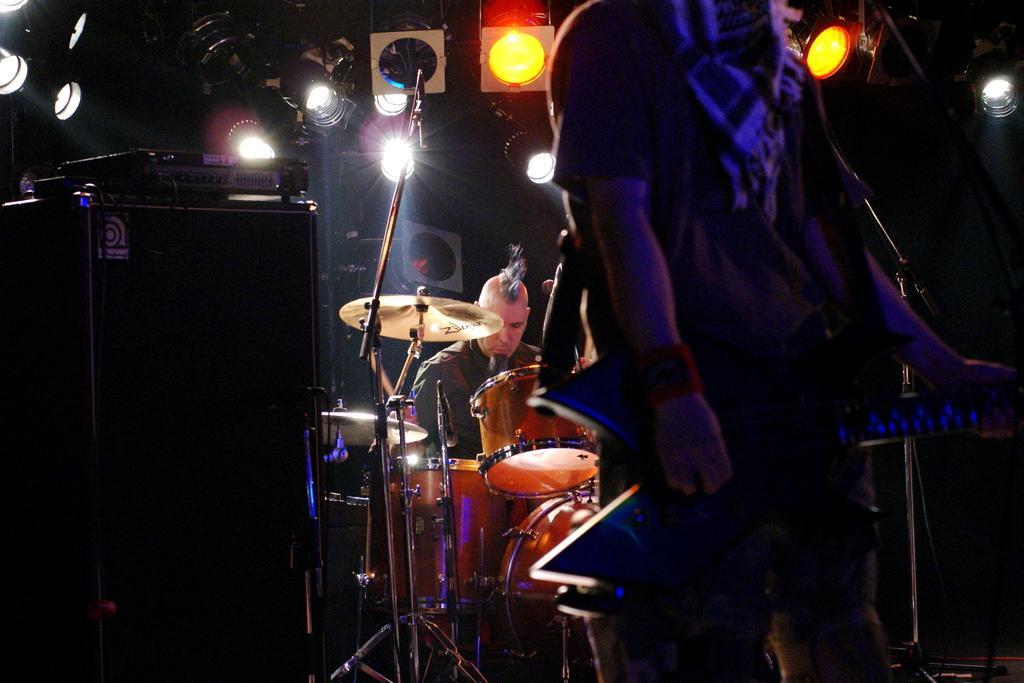Describe this image in one or two sentences. This picture shows a man standing and another man seated and playing drums we see a microphone 